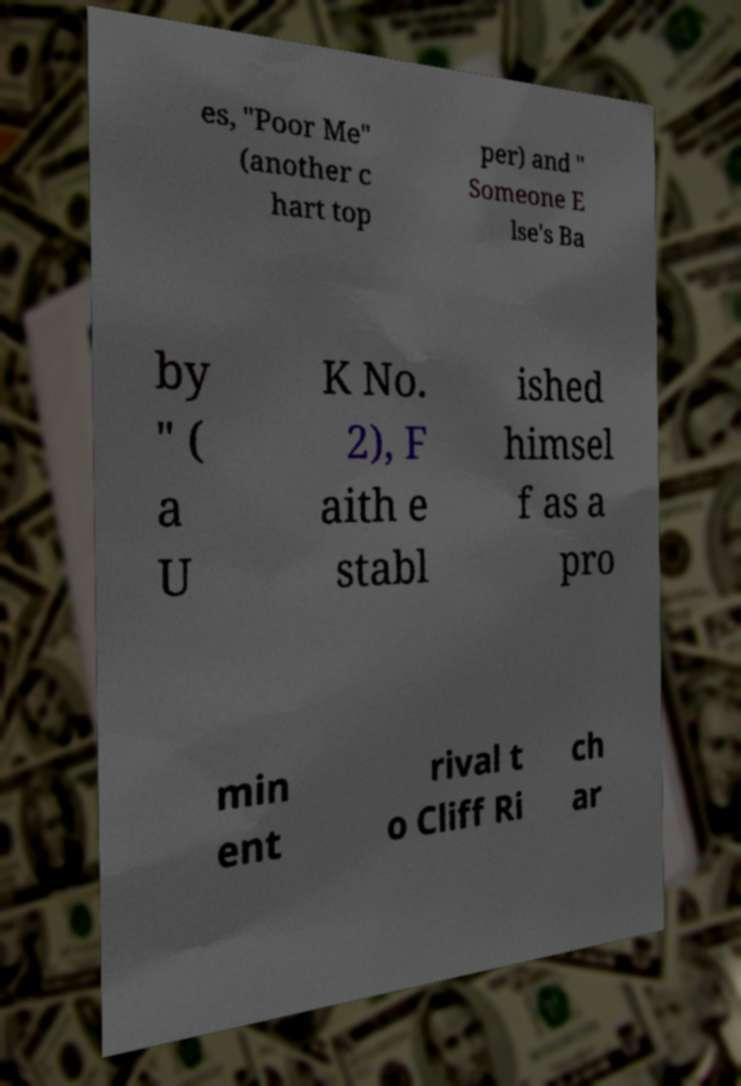Could you assist in decoding the text presented in this image and type it out clearly? es, "Poor Me" (another c hart top per) and " Someone E lse's Ba by " ( a U K No. 2), F aith e stabl ished himsel f as a pro min ent rival t o Cliff Ri ch ar 